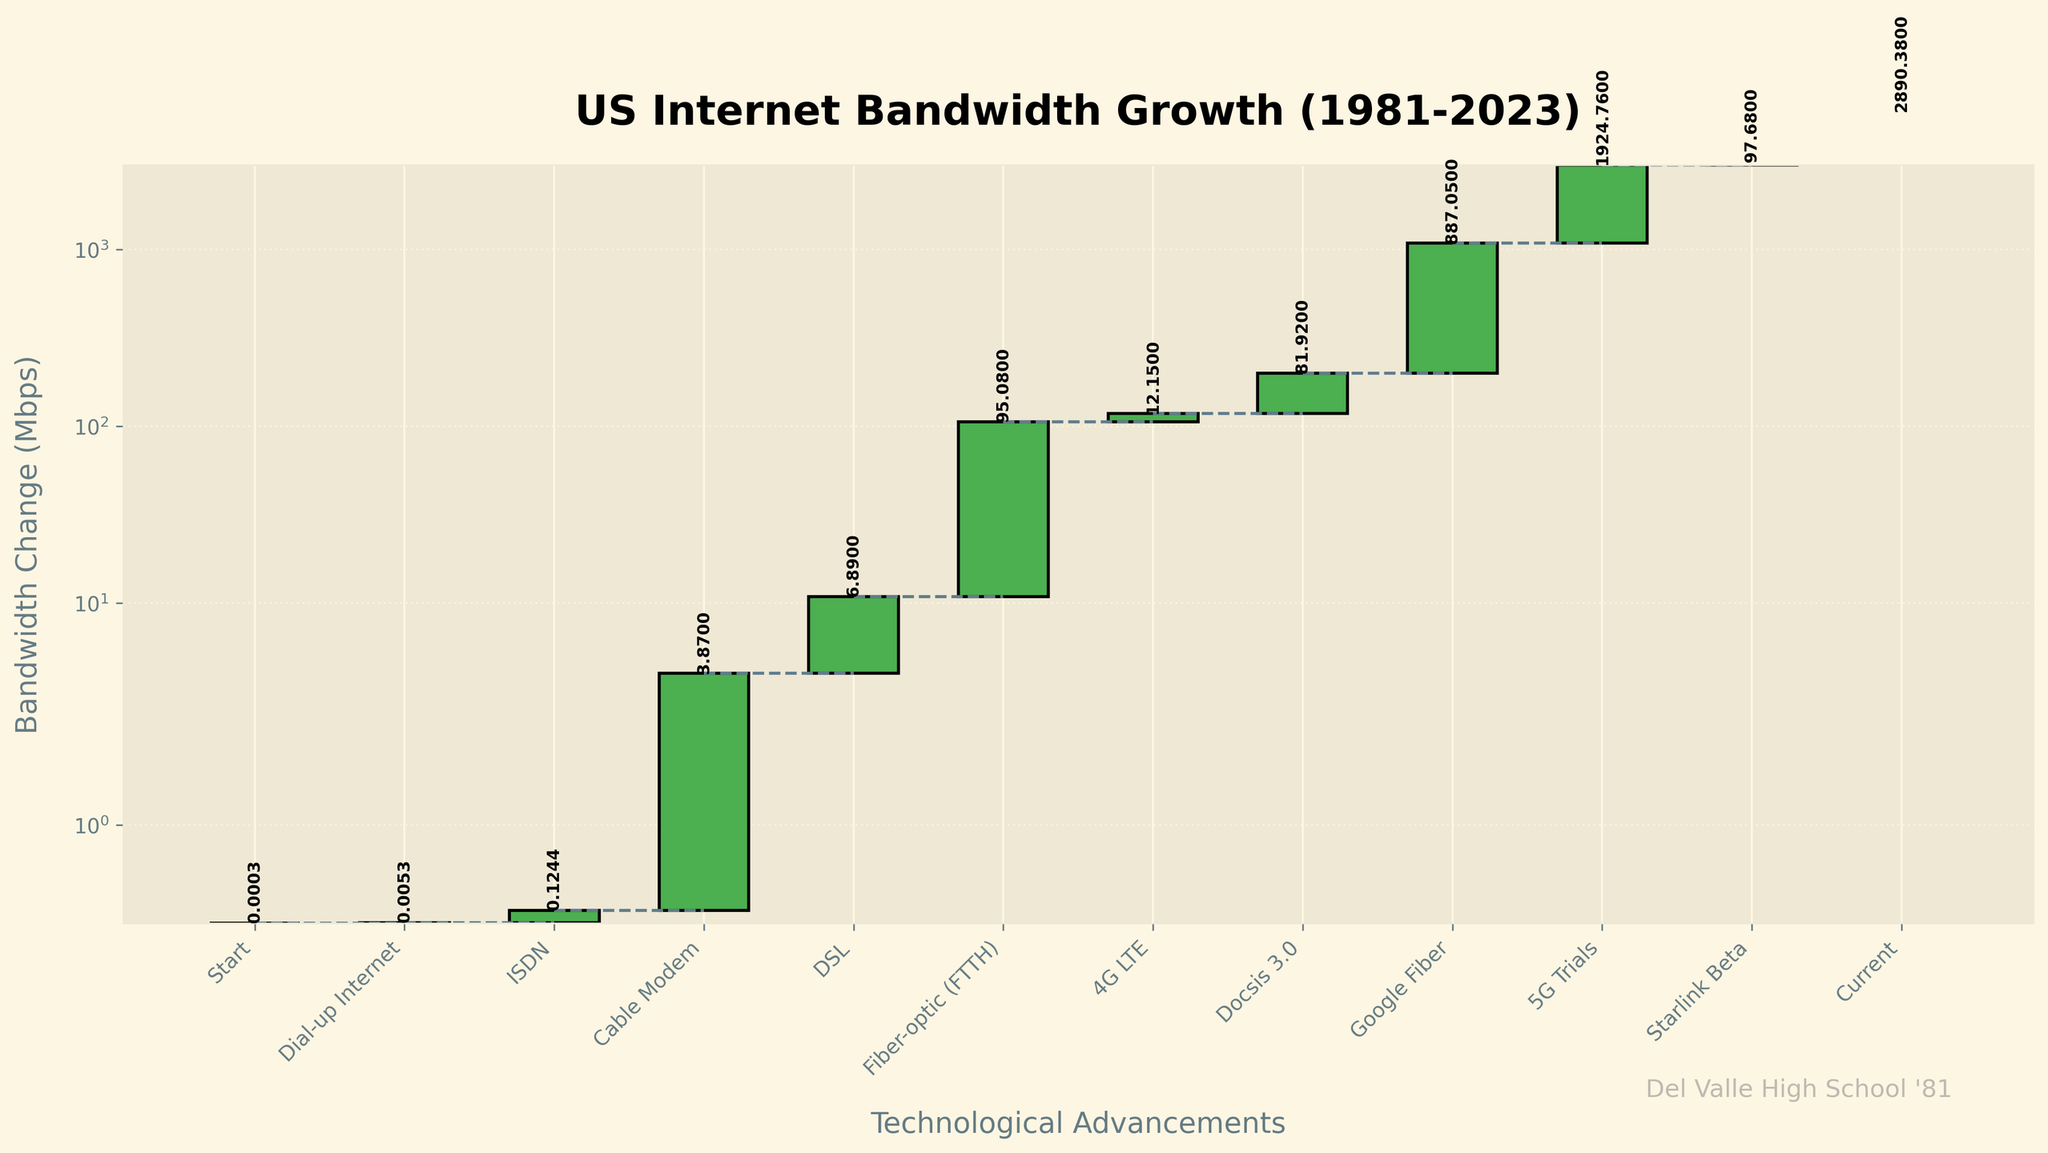What is the title of the graph? The title is displayed at the top of the graph and should be directly read from there.
Answer: US Internet Bandwidth Growth (1981-2023) How many major technological advancements are depicted in the graph? Each bar in the waterfall chart represents a technological advancement. Count the number of bars to determine the total.
Answer: 11 What advancement caused the largest increase in bandwidth? Look for the tallest bar on the chart. The tallest bar indicates the technological advancement that led to the largest increase in bandwidth.
Answer: Google Fiber Between which two advancements did the bandwidth change the most? Identify the two adjacent bars with the largest visible height difference. This indicates the biggest change in bandwidth between two consecutive advancements.
Answer: Between 2013 (Google Fiber) and 2016 (5G Trials) How does the Starlink Beta bandwidth increase (2020) compare to the 4G LTE increase (2007)? Compare the height of the bars for 4G LTE in 2007 to Starlink Beta in 2020.
Answer: Starlink Beta increased more than 4G LTE Which technological advancement introduced after 2000 had the least impact on bandwidth? Examine the bars representing advancements post-2000, looking for the shortest bar.
Answer: 4G LTE What is the cumulative bandwidth increase from 1981 to 2023? The top of the final bar represents the cumulative sum of all previous bandwidth changes.
Answer: 2890.38 Mbps How did the bandwidth change from ISDN in 1995 to Cable Modem in 1997? Subtract the ISDN bandwidth from the Cable Modem bandwidth to find the increase. ISDN (0.1244) and Cable Modem (3.87), thus 3.87 - 0.1244.
Answer: 3.7456 Mbps What is the difference in bandwidth change between DSL in 2001 and Docsis 3.0 in 2010? Subtract the DSL bandwidth from the Docsis 3.0 bandwidth. DSL (6.89) and Docsis 3.0 (81.92), thus 81.92 - 6.89.
Answer: 75.03 Mbps Identify the first major increase in bandwidth within the chart. Look for the first significant jump in the bar heights starting from the left-most bar representing the earliest year.
Answer: Cable Modem in 1997 